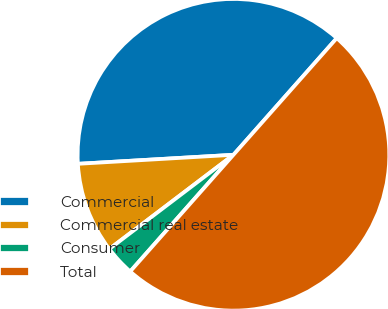Convert chart. <chart><loc_0><loc_0><loc_500><loc_500><pie_chart><fcel>Commercial<fcel>Commercial real estate<fcel>Consumer<fcel>Total<nl><fcel>37.46%<fcel>9.41%<fcel>3.14%<fcel>50.0%<nl></chart> 